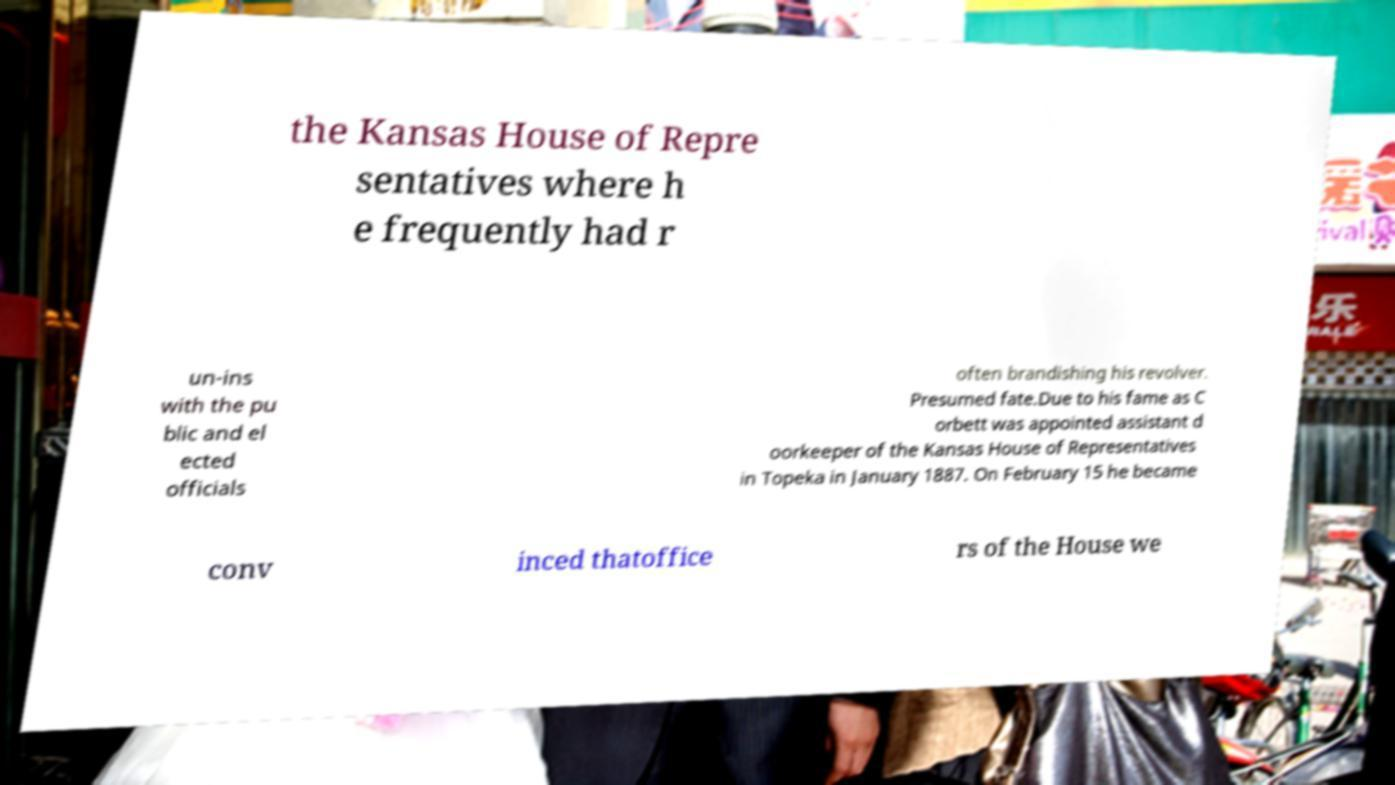Can you read and provide the text displayed in the image?This photo seems to have some interesting text. Can you extract and type it out for me? the Kansas House of Repre sentatives where h e frequently had r un-ins with the pu blic and el ected officials often brandishing his revolver. Presumed fate.Due to his fame as C orbett was appointed assistant d oorkeeper of the Kansas House of Representatives in Topeka in January 1887. On February 15 he became conv inced thatoffice rs of the House we 